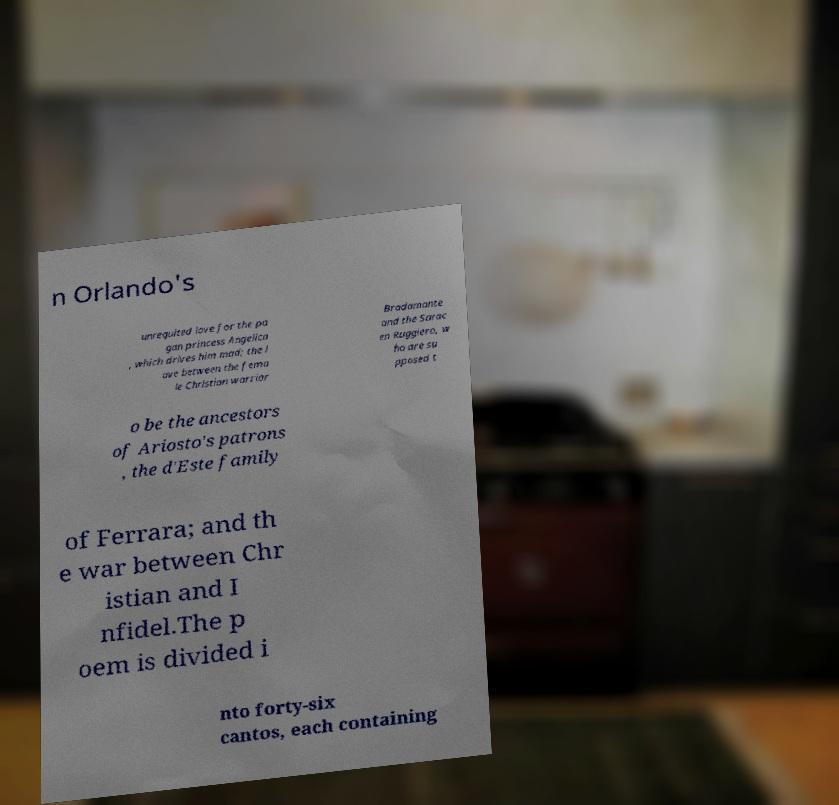Could you extract and type out the text from this image? n Orlando's unrequited love for the pa gan princess Angelica , which drives him mad; the l ove between the fema le Christian warrior Bradamante and the Sarac en Ruggiero, w ho are su pposed t o be the ancestors of Ariosto's patrons , the d'Este family of Ferrara; and th e war between Chr istian and I nfidel.The p oem is divided i nto forty-six cantos, each containing 